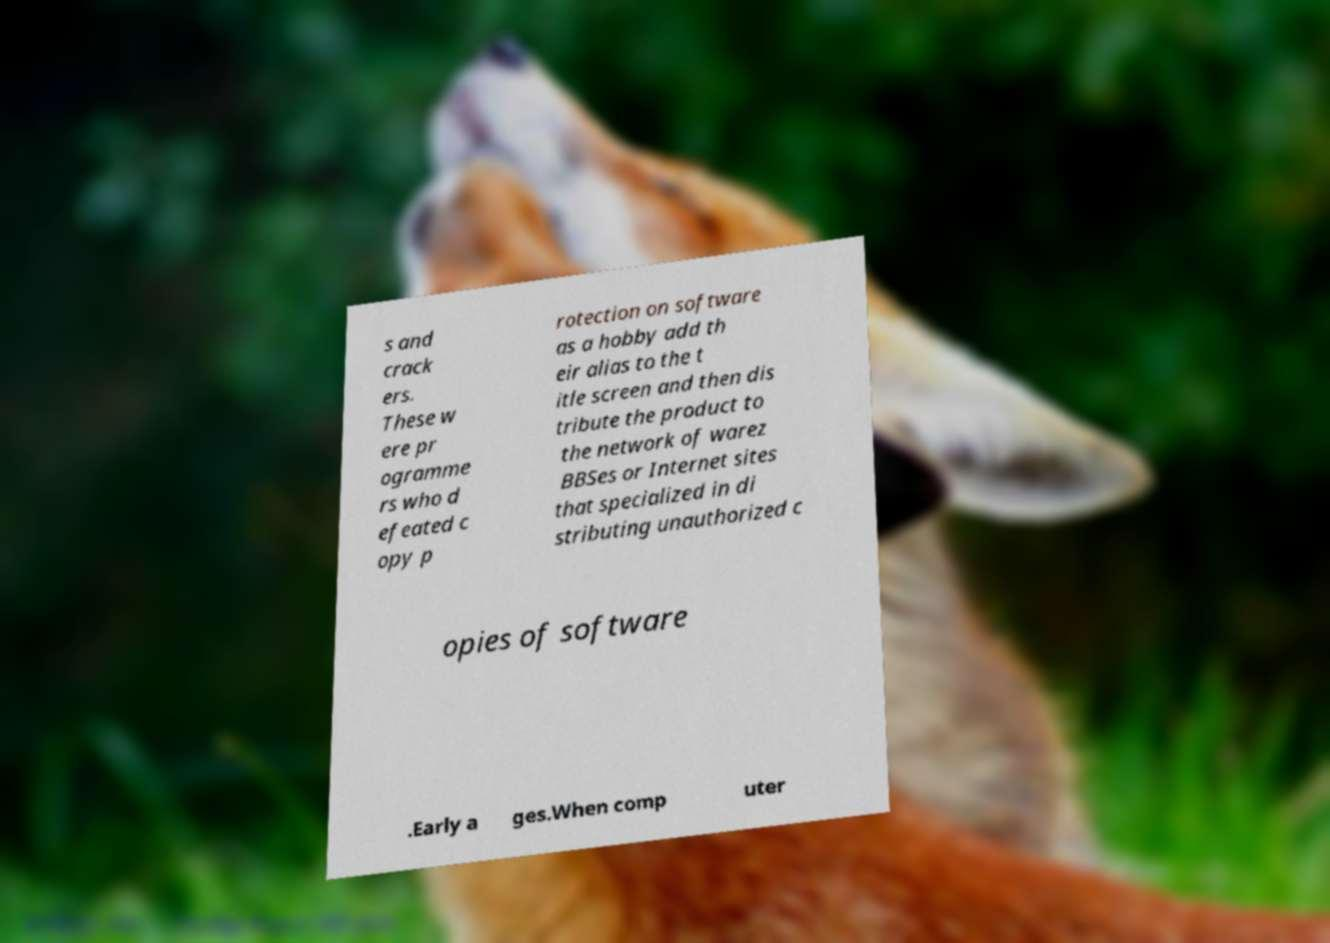Please read and relay the text visible in this image. What does it say? s and crack ers. These w ere pr ogramme rs who d efeated c opy p rotection on software as a hobby add th eir alias to the t itle screen and then dis tribute the product to the network of warez BBSes or Internet sites that specialized in di stributing unauthorized c opies of software .Early a ges.When comp uter 